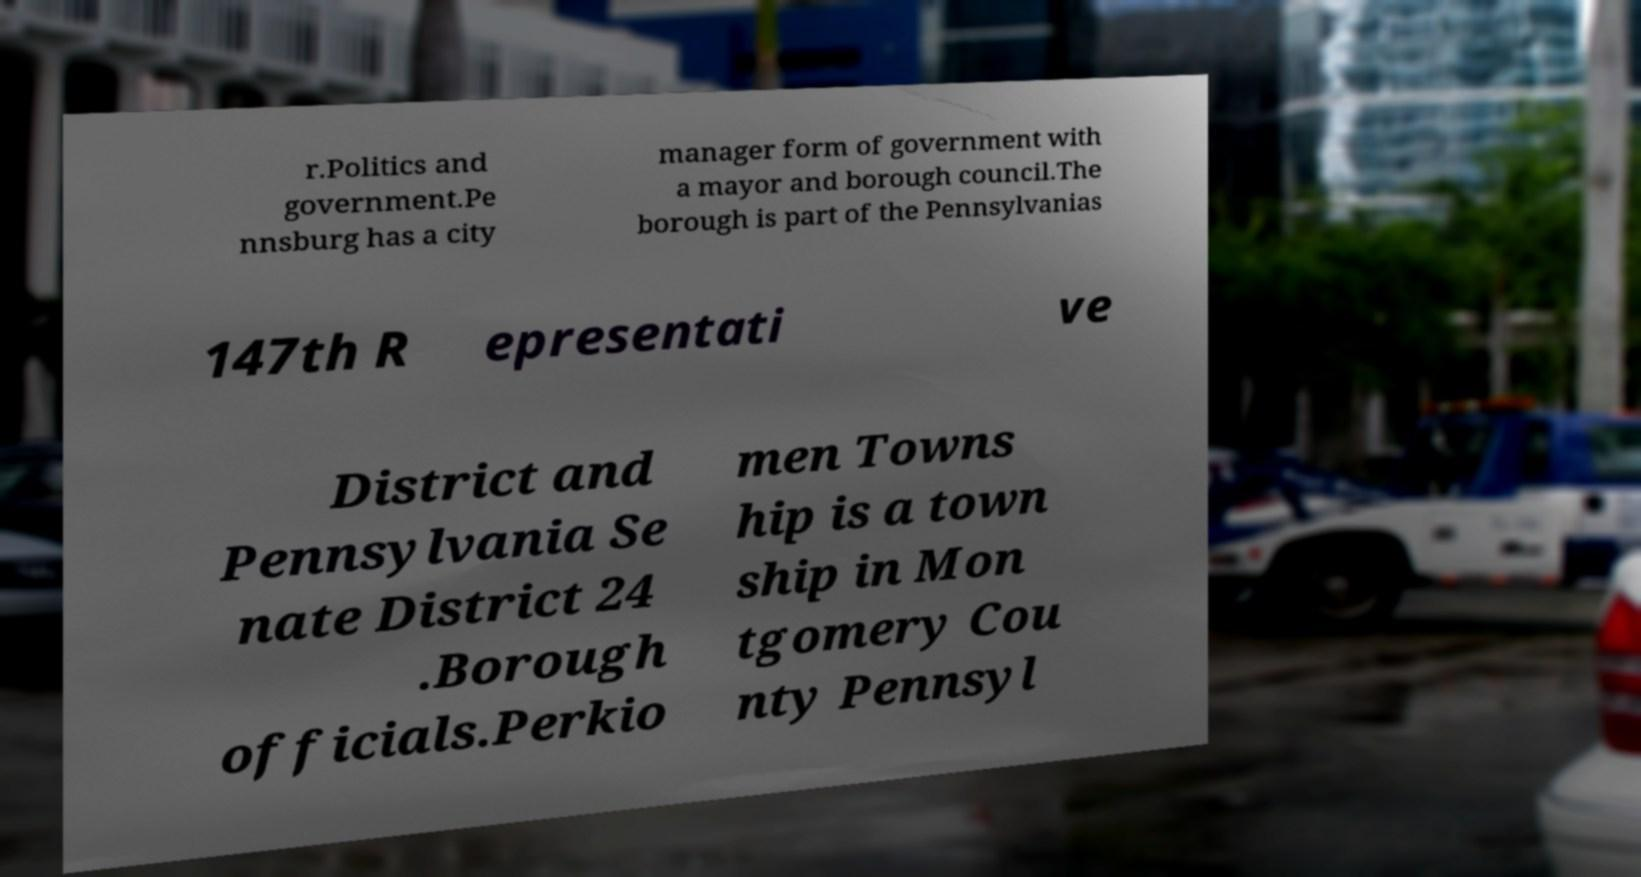Can you accurately transcribe the text from the provided image for me? r.Politics and government.Pe nnsburg has a city manager form of government with a mayor and borough council.The borough is part of the Pennsylvanias 147th R epresentati ve District and Pennsylvania Se nate District 24 .Borough officials.Perkio men Towns hip is a town ship in Mon tgomery Cou nty Pennsyl 